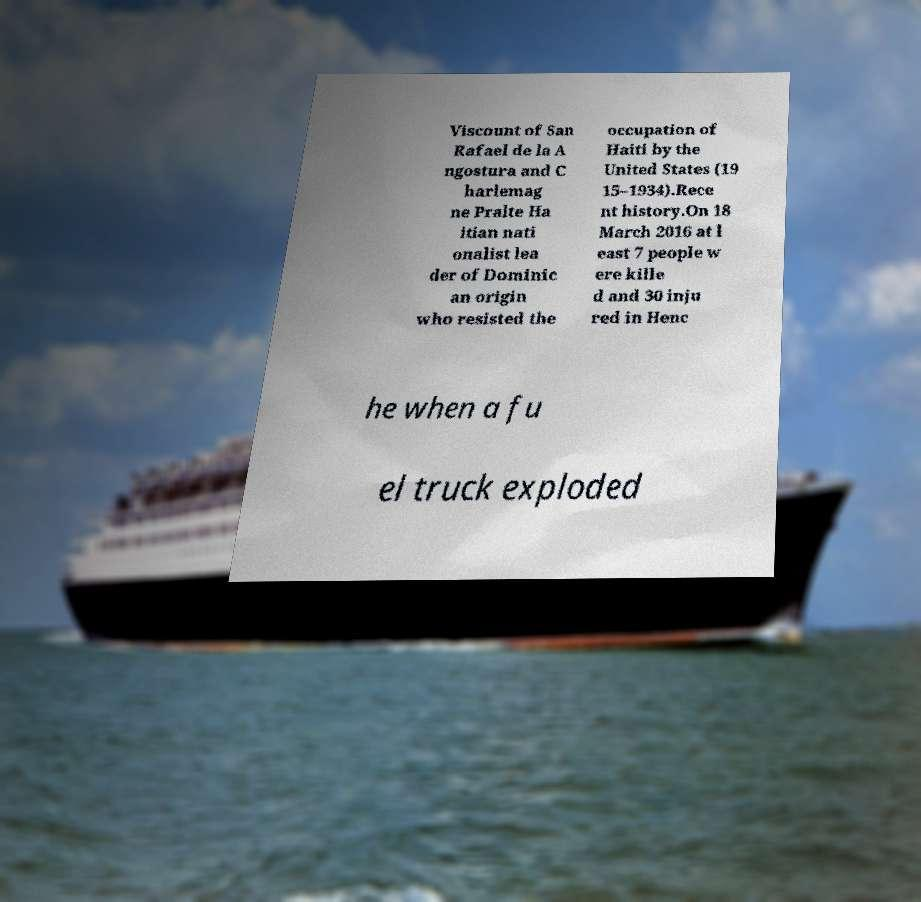Please identify and transcribe the text found in this image. Viscount of San Rafael de la A ngostura and C harlemag ne Pralte Ha itian nati onalist lea der of Dominic an origin who resisted the occupation of Haiti by the United States (19 15–1934).Rece nt history.On 18 March 2016 at l east 7 people w ere kille d and 30 inju red in Henc he when a fu el truck exploded 